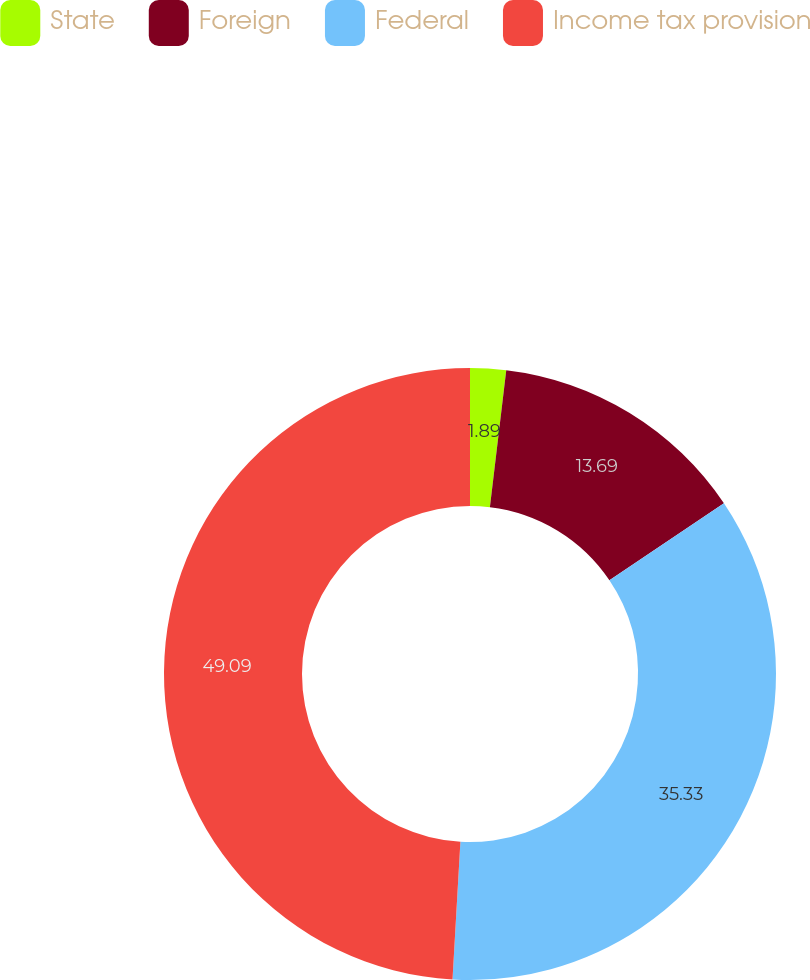<chart> <loc_0><loc_0><loc_500><loc_500><pie_chart><fcel>State<fcel>Foreign<fcel>Federal<fcel>Income tax provision<nl><fcel>1.89%<fcel>13.69%<fcel>35.33%<fcel>49.09%<nl></chart> 